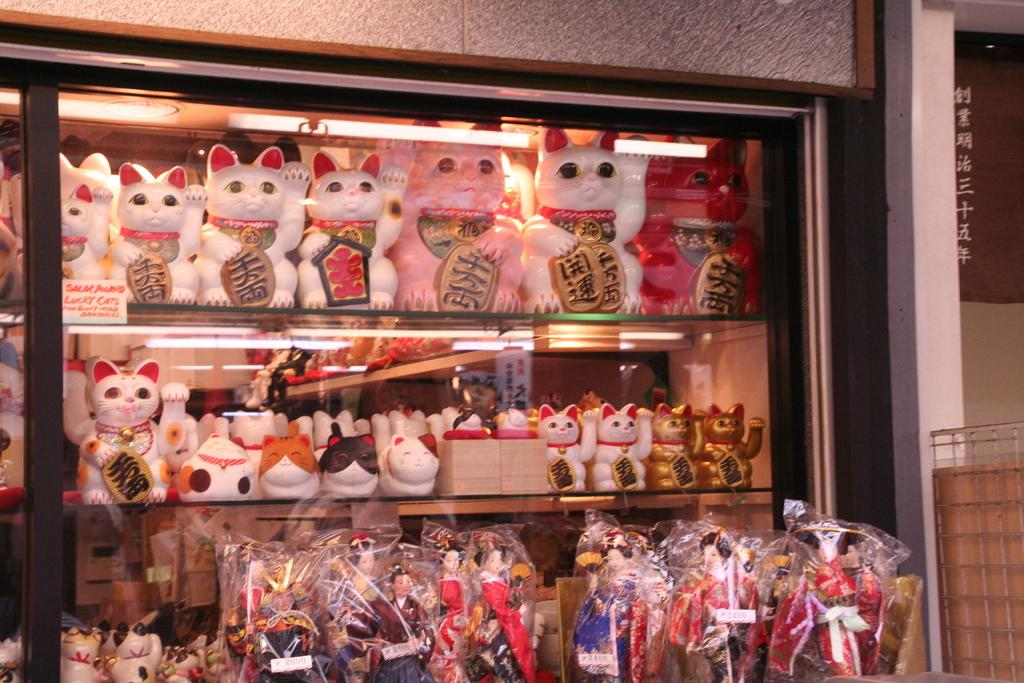What can be seen on the rack in the image? There is a rack filled with toys in the image. What is located on the right side of the image? There is a wall and railing on the right side of the image. What type of rice can be seen growing on the wall in the image? There is no rice growing on the wall in the image; it features a wall and railing on the right side. What form does the mist take in the image? There is no mist present in the image. 